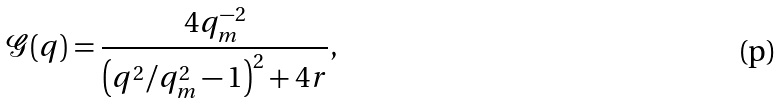<formula> <loc_0><loc_0><loc_500><loc_500>\mathcal { G } ( q ) = \frac { 4 q _ { m } ^ { - 2 } } { \left ( q ^ { 2 } / q _ { m } ^ { 2 } - 1 \right ) ^ { 2 } + 4 r } ,</formula> 